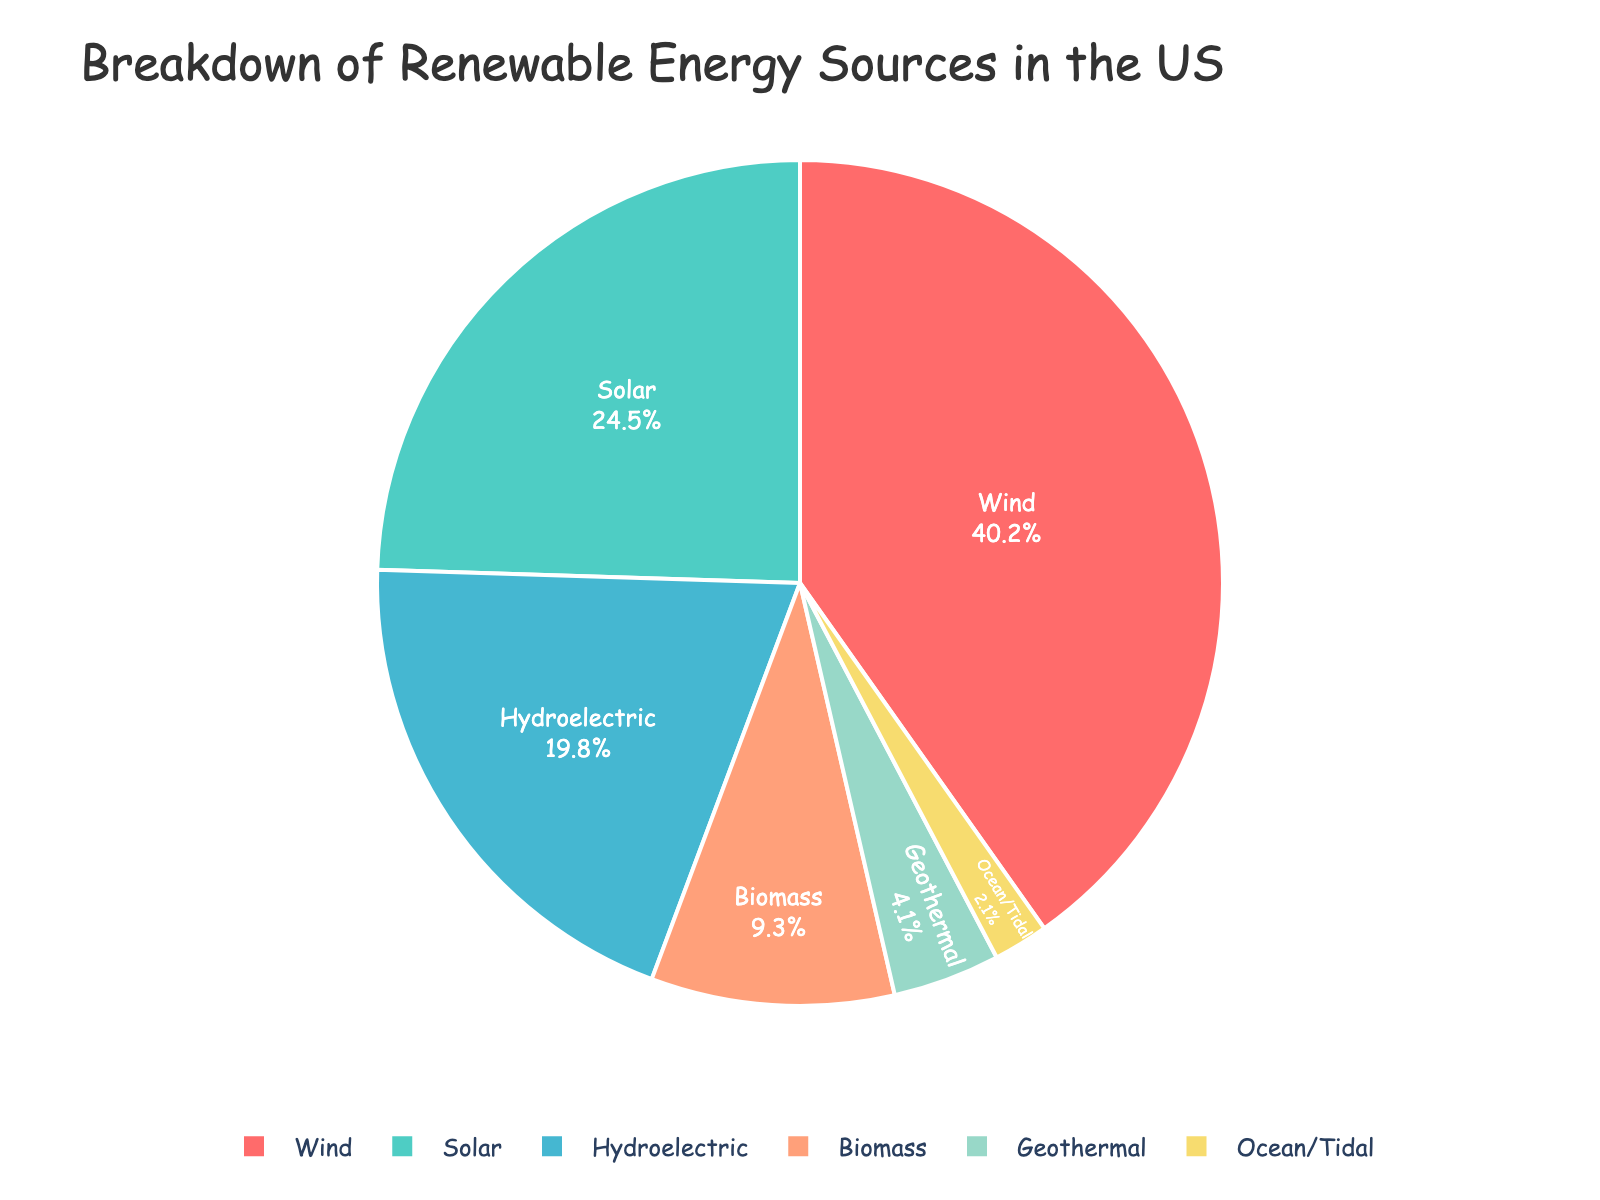Which renewable energy source has the greatest percentage? The source with the largest slice of the pie chart has the greatest percentage. In the chart, the largest slice corresponds to Wind.
Answer: Wind Which renewable energy source has the smallest percentage? The smallest slice of the pie chart represents the smallest percentage. In the chart, the smallest slice corresponds to Ocean/Tidal.
Answer: Ocean/Tidal What is the combined percentage of Solar and Hydroelectric energy sources? Sum the percentages of Solar (24.5) and Hydroelectric (19.8). 24.5 + 19.8 = 44.3
Answer: 44.3 Is Biomass energy percentage greater than Geothermal energy percentage? Compare the percentages of Biomass (9.3) and Geothermal (4.1). Since 9.3 is greater than 4.1, Biomass is greater.
Answer: Yes How does the percentage of Wind energy compare to the sum of Solar and Geothermal? Calculate the sum of Solar (24.5) and Geothermal (4.1), which is 24.5 + 4.1 = 28.6; then compare Wind (40.2) to 28.6. Since 40.2 is greater, Wind is greater.
Answer: Wind is greater What is the total percentage of non-Wind renewable energy sources? Subtract the Wind percentage (40.2) from 100. 100 - 40.2 = 59.8
Answer: 59.8 How many sources have a percentage greater than 10%? Identify sources with percentages greater than 10: Solar (24.5), Wind (40.2), Hydroelectric (19.8). Counting these, we have 3 sources.
Answer: 3 What is the average percentage of Biomass and Ocean/Tidal energy sources? Sum the percentages of Biomass (9.3) and Ocean/Tidal (2.1), then divide by 2. (9.3 + 2.1) / 2 = 5.7
Answer: 5.7 Which color represents Hydroelectric energy in the pie chart? Locate the slice labeled Hydroelectric and note its color. The Hydroelectric slice is yellowish (FE7E6B).
Answer: Yellowish What is the total percentage of Geothermal, Biomass, and Ocean/Tidal combined? Sum the percentages of Geothermal (4.1), Biomass (9.3), and Ocean/Tidal (2.1). 4.1 + 9.3 + 2.1 = 15.5
Answer: 15.5 